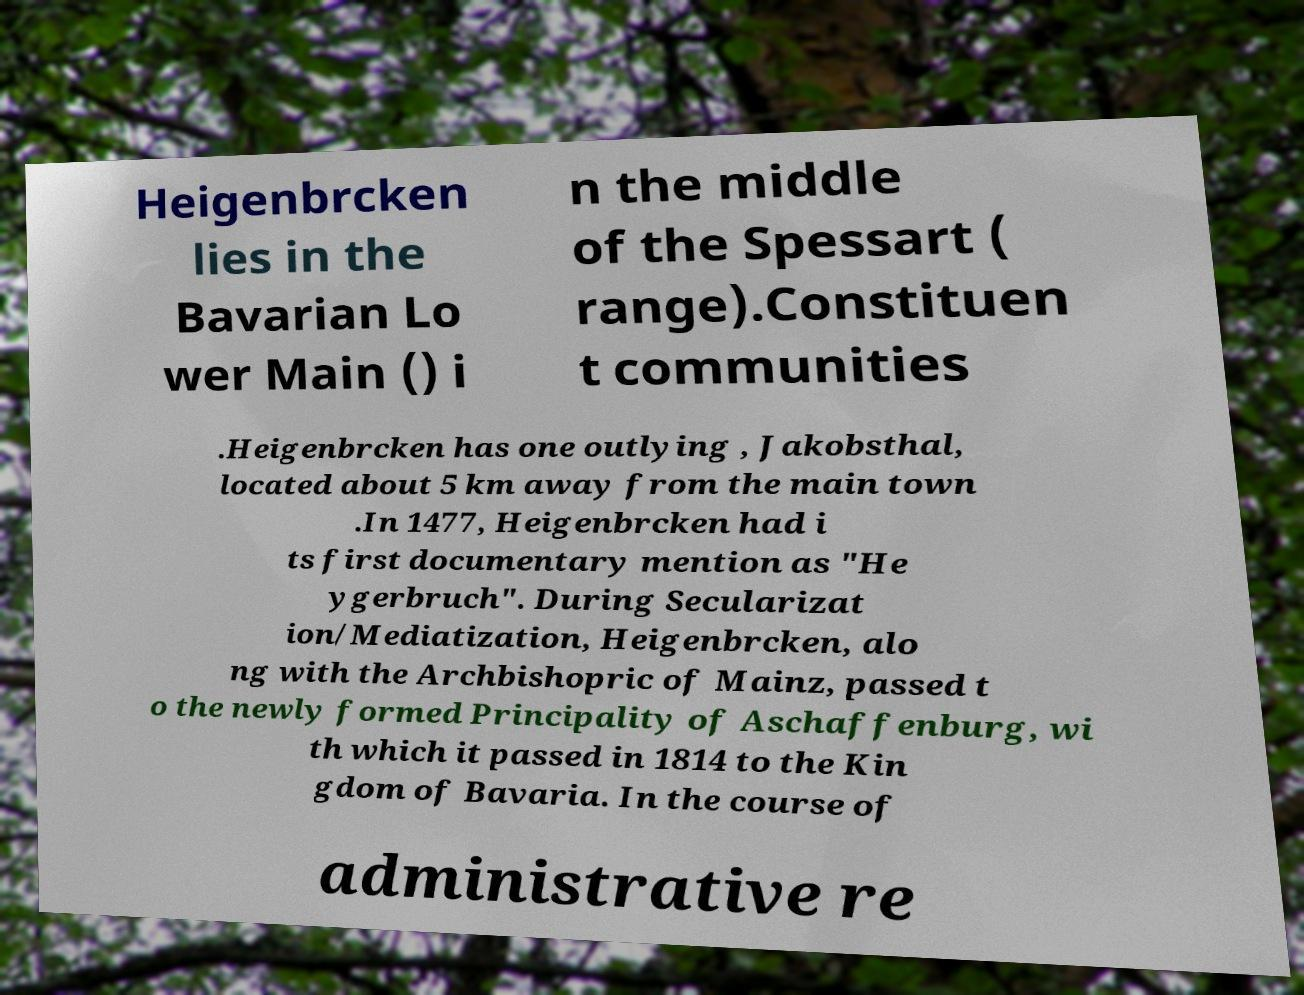Please read and relay the text visible in this image. What does it say? Heigenbrcken lies in the Bavarian Lo wer Main () i n the middle of the Spessart ( range).Constituen t communities .Heigenbrcken has one outlying , Jakobsthal, located about 5 km away from the main town .In 1477, Heigenbrcken had i ts first documentary mention as "He ygerbruch". During Secularizat ion/Mediatization, Heigenbrcken, alo ng with the Archbishopric of Mainz, passed t o the newly formed Principality of Aschaffenburg, wi th which it passed in 1814 to the Kin gdom of Bavaria. In the course of administrative re 